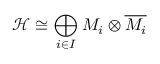Convert formula to latex. <formula><loc_0><loc_0><loc_500><loc_500>{ \mathcal { H } } \cong \bigoplus _ { i \in I } M _ { i } \otimes { \overline { { M _ { i } } } }</formula> 